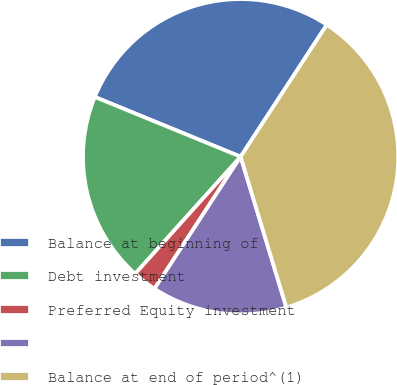Convert chart. <chart><loc_0><loc_0><loc_500><loc_500><pie_chart><fcel>Balance at beginning of<fcel>Debt investment<fcel>Preferred Equity investment<fcel>Unnamed: 3<fcel>Balance at end of period^(1)<nl><fcel>28.02%<fcel>19.52%<fcel>2.47%<fcel>13.89%<fcel>36.11%<nl></chart> 